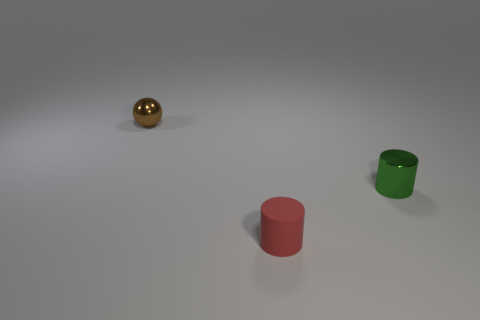Add 2 small objects. How many objects exist? 5 Subtract all cylinders. How many objects are left? 1 Subtract all brown cylinders. Subtract all green cubes. How many cylinders are left? 2 Subtract all small red rubber things. Subtract all brown metal spheres. How many objects are left? 1 Add 1 brown balls. How many brown balls are left? 2 Add 3 metal objects. How many metal objects exist? 5 Subtract 0 purple blocks. How many objects are left? 3 